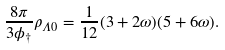<formula> <loc_0><loc_0><loc_500><loc_500>\frac { 8 \pi } { 3 \phi _ { \dagger } } \rho _ { \Lambda 0 } = \frac { 1 } { 1 2 } ( 3 + 2 \omega ) ( 5 + 6 \omega ) .</formula> 